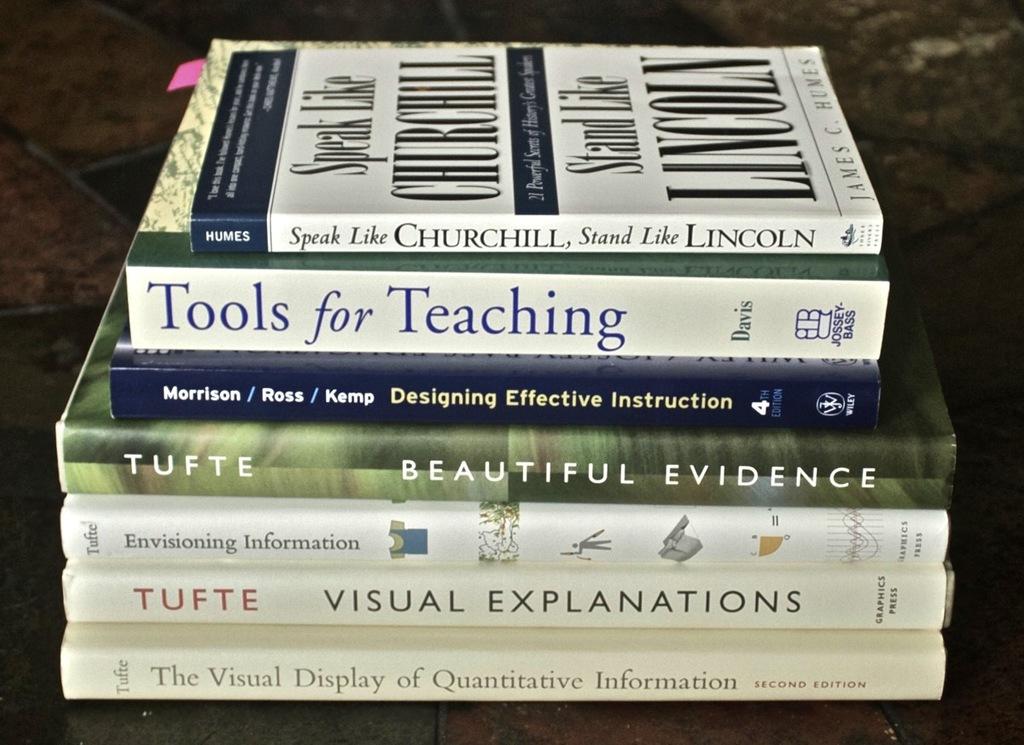What's the title of the last book?
Give a very brief answer. The visual display of quantitative information. 